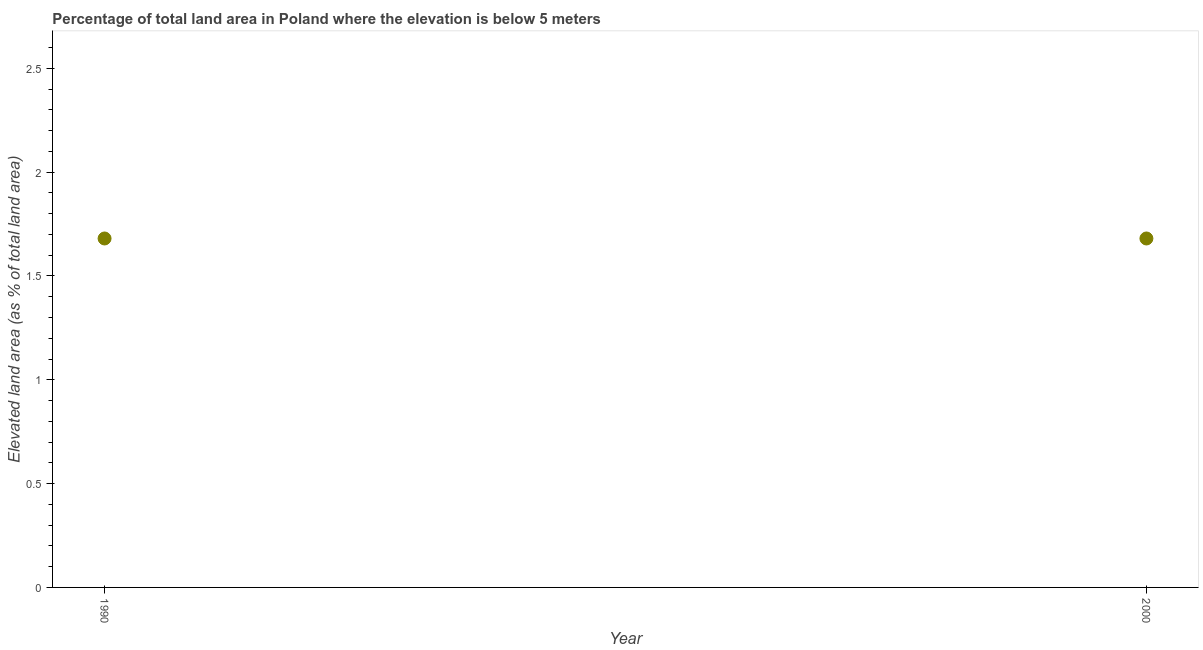What is the total elevated land area in 1990?
Your response must be concise. 1.68. Across all years, what is the maximum total elevated land area?
Provide a succinct answer. 1.68. Across all years, what is the minimum total elevated land area?
Your answer should be compact. 1.68. In which year was the total elevated land area maximum?
Your answer should be very brief. 1990. What is the sum of the total elevated land area?
Offer a very short reply. 3.36. What is the average total elevated land area per year?
Your answer should be compact. 1.68. What is the median total elevated land area?
Make the answer very short. 1.68. In how many years, is the total elevated land area greater than 2.3 %?
Give a very brief answer. 0. In how many years, is the total elevated land area greater than the average total elevated land area taken over all years?
Provide a succinct answer. 0. How many dotlines are there?
Provide a succinct answer. 1. How many years are there in the graph?
Ensure brevity in your answer.  2. What is the difference between two consecutive major ticks on the Y-axis?
Your answer should be very brief. 0.5. Are the values on the major ticks of Y-axis written in scientific E-notation?
Offer a terse response. No. Does the graph contain any zero values?
Offer a very short reply. No. What is the title of the graph?
Your response must be concise. Percentage of total land area in Poland where the elevation is below 5 meters. What is the label or title of the X-axis?
Provide a short and direct response. Year. What is the label or title of the Y-axis?
Your answer should be very brief. Elevated land area (as % of total land area). What is the Elevated land area (as % of total land area) in 1990?
Your answer should be compact. 1.68. What is the Elevated land area (as % of total land area) in 2000?
Your answer should be compact. 1.68. What is the difference between the Elevated land area (as % of total land area) in 1990 and 2000?
Ensure brevity in your answer.  0. What is the ratio of the Elevated land area (as % of total land area) in 1990 to that in 2000?
Keep it short and to the point. 1. 